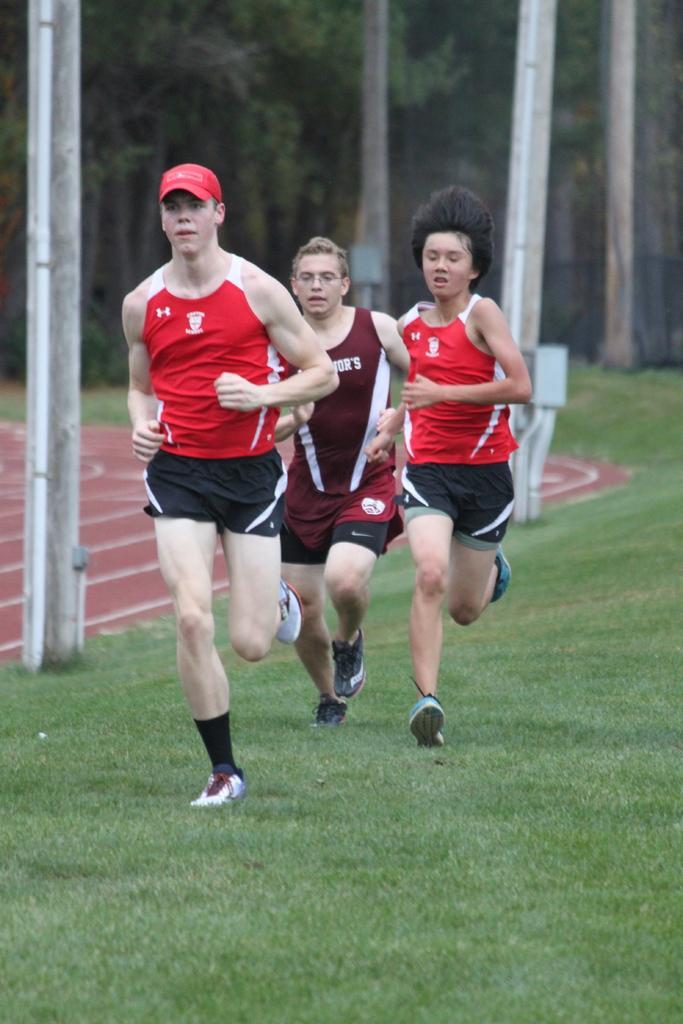In one or two sentences, can you explain what this image depicts? There people running on the grass. We can see poles. In the background we can see trees and ground. 